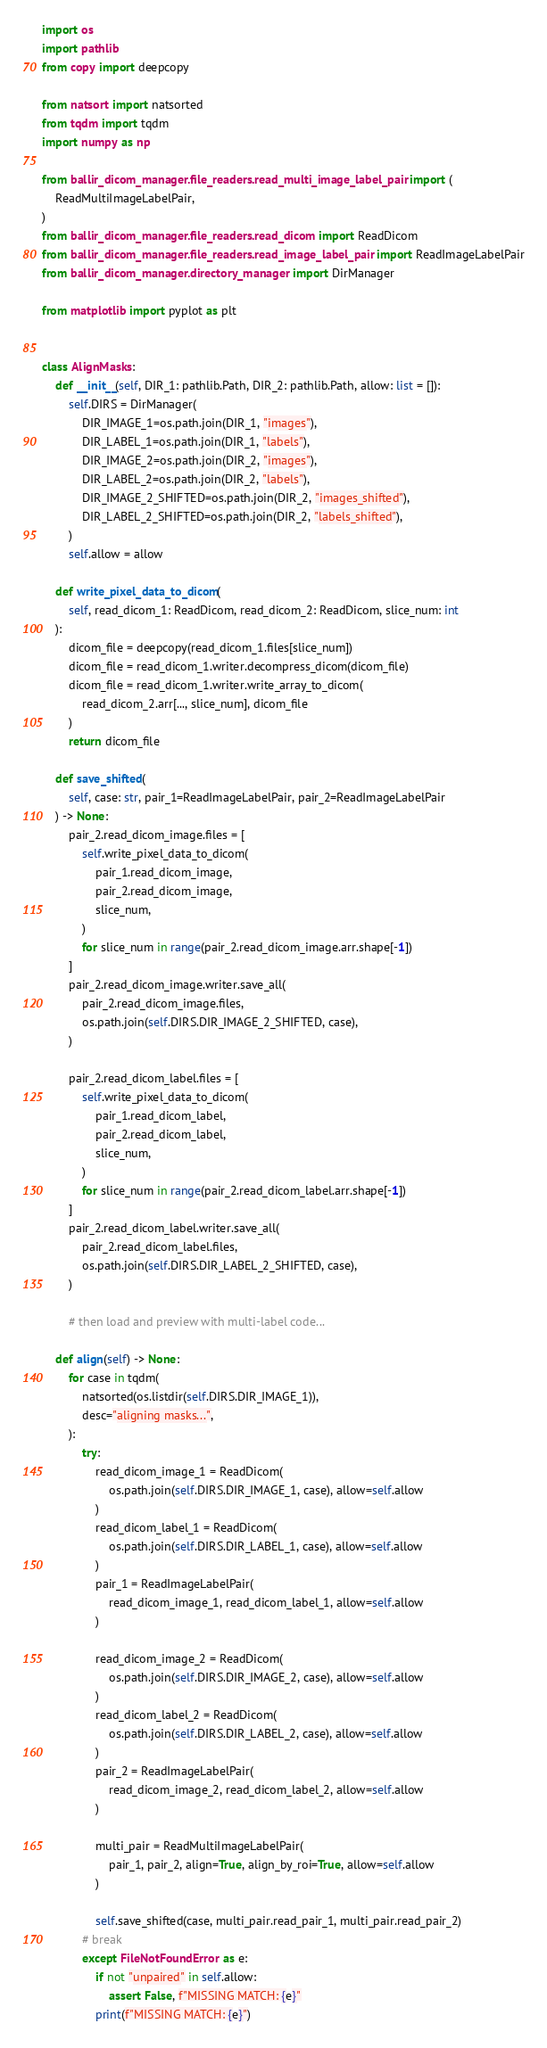<code> <loc_0><loc_0><loc_500><loc_500><_Python_>import os
import pathlib
from copy import deepcopy

from natsort import natsorted
from tqdm import tqdm
import numpy as np

from ballir_dicom_manager.file_readers.read_multi_image_label_pair import (
    ReadMultiImageLabelPair,
)
from ballir_dicom_manager.file_readers.read_dicom import ReadDicom
from ballir_dicom_manager.file_readers.read_image_label_pair import ReadImageLabelPair
from ballir_dicom_manager.directory_manager import DirManager

from matplotlib import pyplot as plt


class AlignMasks:
    def __init__(self, DIR_1: pathlib.Path, DIR_2: pathlib.Path, allow: list = []):
        self.DIRS = DirManager(
            DIR_IMAGE_1=os.path.join(DIR_1, "images"),
            DIR_LABEL_1=os.path.join(DIR_1, "labels"),
            DIR_IMAGE_2=os.path.join(DIR_2, "images"),
            DIR_LABEL_2=os.path.join(DIR_2, "labels"),
            DIR_IMAGE_2_SHIFTED=os.path.join(DIR_2, "images_shifted"),
            DIR_LABEL_2_SHIFTED=os.path.join(DIR_2, "labels_shifted"),
        )
        self.allow = allow

    def write_pixel_data_to_dicom(
        self, read_dicom_1: ReadDicom, read_dicom_2: ReadDicom, slice_num: int
    ):
        dicom_file = deepcopy(read_dicom_1.files[slice_num])
        dicom_file = read_dicom_1.writer.decompress_dicom(dicom_file)
        dicom_file = read_dicom_1.writer.write_array_to_dicom(
            read_dicom_2.arr[..., slice_num], dicom_file
        )
        return dicom_file

    def save_shifted(
        self, case: str, pair_1=ReadImageLabelPair, pair_2=ReadImageLabelPair
    ) -> None:
        pair_2.read_dicom_image.files = [
            self.write_pixel_data_to_dicom(
                pair_1.read_dicom_image,
                pair_2.read_dicom_image,
                slice_num,
            )
            for slice_num in range(pair_2.read_dicom_image.arr.shape[-1])
        ]
        pair_2.read_dicom_image.writer.save_all(
            pair_2.read_dicom_image.files,
            os.path.join(self.DIRS.DIR_IMAGE_2_SHIFTED, case),
        )

        pair_2.read_dicom_label.files = [
            self.write_pixel_data_to_dicom(
                pair_1.read_dicom_label,
                pair_2.read_dicom_label,
                slice_num,
            )
            for slice_num in range(pair_2.read_dicom_label.arr.shape[-1])
        ]
        pair_2.read_dicom_label.writer.save_all(
            pair_2.read_dicom_label.files,
            os.path.join(self.DIRS.DIR_LABEL_2_SHIFTED, case),
        )

        # then load and preview with multi-label code...

    def align(self) -> None:
        for case in tqdm(
            natsorted(os.listdir(self.DIRS.DIR_IMAGE_1)),
            desc="aligning masks...",
        ):
            try:
                read_dicom_image_1 = ReadDicom(
                    os.path.join(self.DIRS.DIR_IMAGE_1, case), allow=self.allow
                )
                read_dicom_label_1 = ReadDicom(
                    os.path.join(self.DIRS.DIR_LABEL_1, case), allow=self.allow
                )
                pair_1 = ReadImageLabelPair(
                    read_dicom_image_1, read_dicom_label_1, allow=self.allow
                )

                read_dicom_image_2 = ReadDicom(
                    os.path.join(self.DIRS.DIR_IMAGE_2, case), allow=self.allow
                )
                read_dicom_label_2 = ReadDicom(
                    os.path.join(self.DIRS.DIR_LABEL_2, case), allow=self.allow
                )
                pair_2 = ReadImageLabelPair(
                    read_dicom_image_2, read_dicom_label_2, allow=self.allow
                )

                multi_pair = ReadMultiImageLabelPair(
                    pair_1, pair_2, align=True, align_by_roi=True, allow=self.allow
                )

                self.save_shifted(case, multi_pair.read_pair_1, multi_pair.read_pair_2)
            # break
            except FileNotFoundError as e:
                if not "unpaired" in self.allow:
                    assert False, f"MISSING MATCH: {e}"
                print(f"MISSING MATCH: {e}")
</code> 